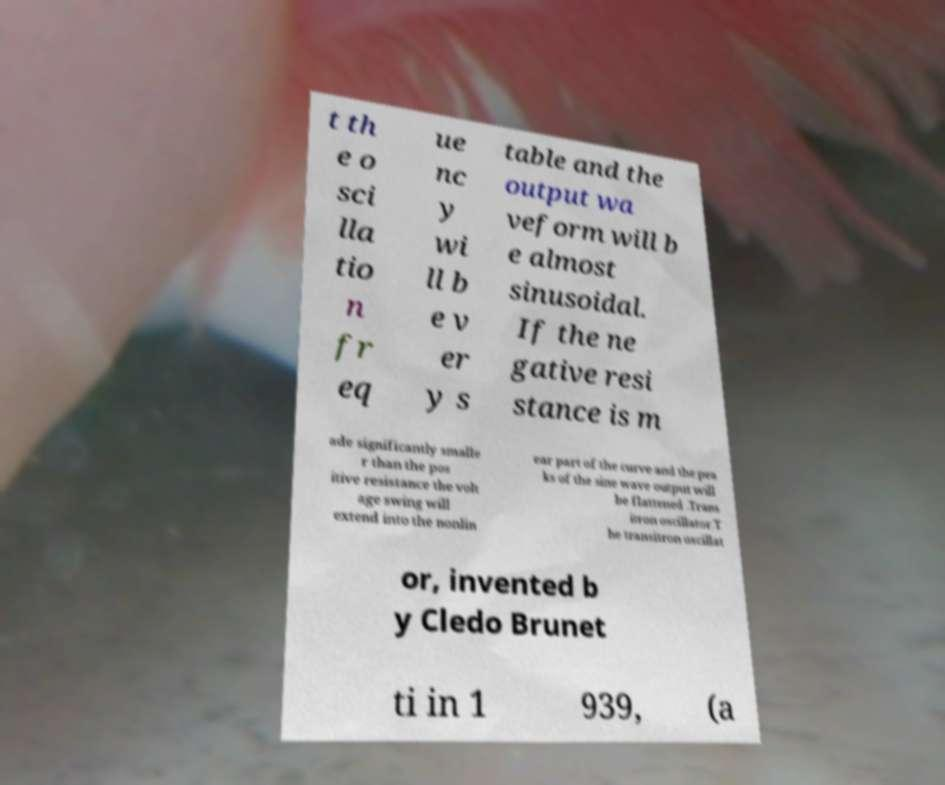Can you read and provide the text displayed in the image?This photo seems to have some interesting text. Can you extract and type it out for me? t th e o sci lla tio n fr eq ue nc y wi ll b e v er y s table and the output wa veform will b e almost sinusoidal. If the ne gative resi stance is m ade significantly smalle r than the pos itive resistance the volt age swing will extend into the nonlin ear part of the curve and the pea ks of the sine wave output will be flattened .Trans itron oscillator.T he transitron oscillat or, invented b y Cledo Brunet ti in 1 939, (a 